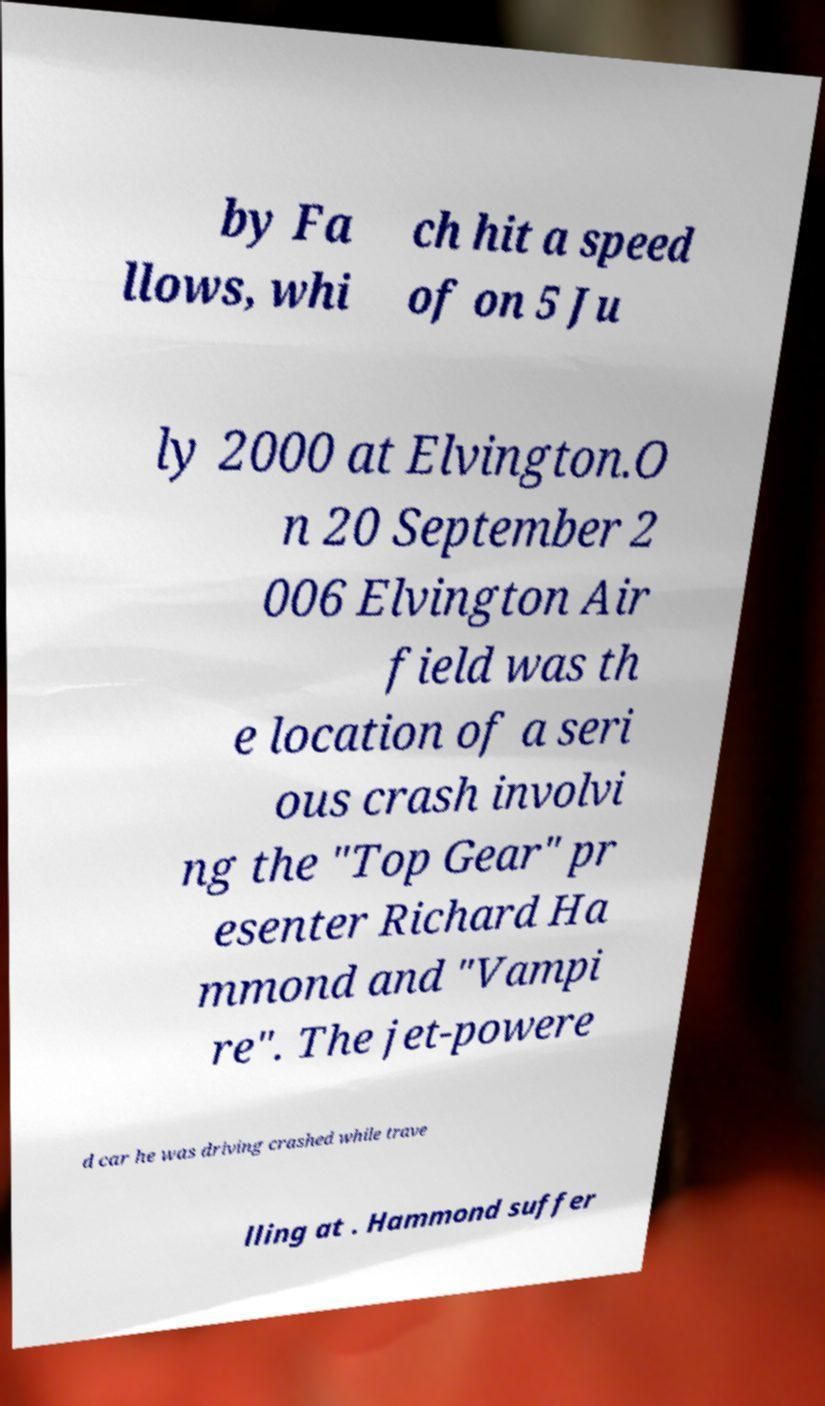Could you extract and type out the text from this image? by Fa llows, whi ch hit a speed of on 5 Ju ly 2000 at Elvington.O n 20 September 2 006 Elvington Air field was th e location of a seri ous crash involvi ng the "Top Gear" pr esenter Richard Ha mmond and "Vampi re". The jet-powere d car he was driving crashed while trave lling at . Hammond suffer 